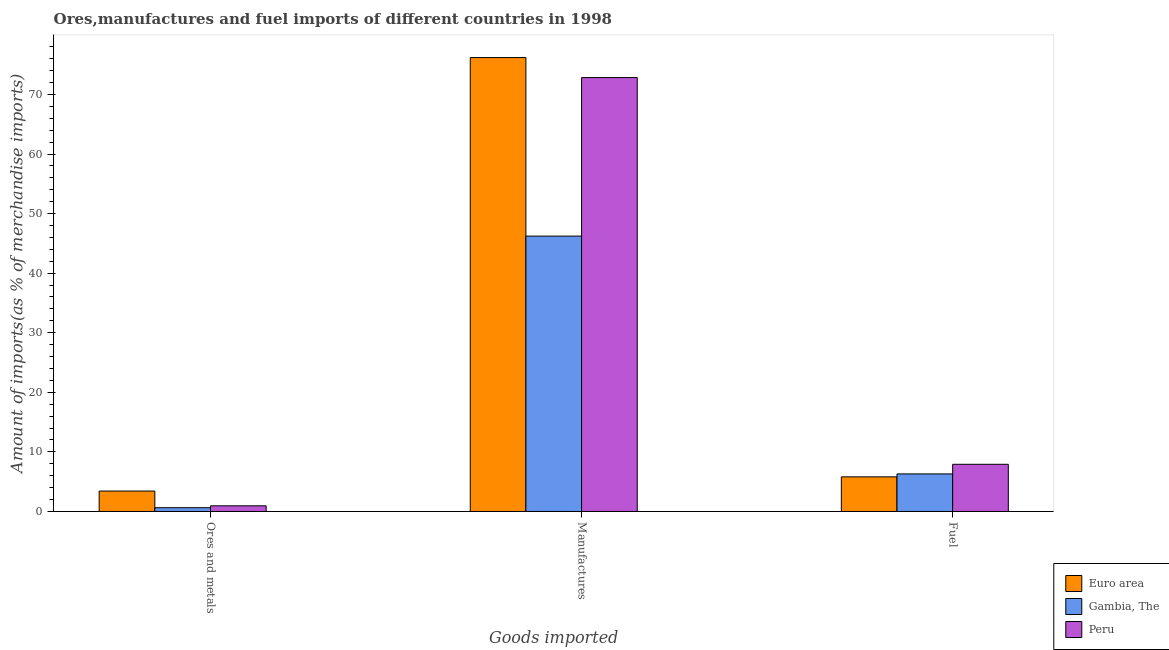How many different coloured bars are there?
Give a very brief answer. 3. Are the number of bars per tick equal to the number of legend labels?
Offer a terse response. Yes. Are the number of bars on each tick of the X-axis equal?
Ensure brevity in your answer.  Yes. How many bars are there on the 3rd tick from the left?
Provide a succinct answer. 3. How many bars are there on the 2nd tick from the right?
Keep it short and to the point. 3. What is the label of the 1st group of bars from the left?
Offer a terse response. Ores and metals. What is the percentage of manufactures imports in Euro area?
Provide a succinct answer. 76.19. Across all countries, what is the maximum percentage of manufactures imports?
Provide a short and direct response. 76.19. Across all countries, what is the minimum percentage of manufactures imports?
Offer a very short reply. 46.22. In which country was the percentage of fuel imports maximum?
Give a very brief answer. Peru. In which country was the percentage of ores and metals imports minimum?
Make the answer very short. Gambia, The. What is the total percentage of ores and metals imports in the graph?
Offer a very short reply. 5.01. What is the difference between the percentage of manufactures imports in Peru and that in Euro area?
Provide a short and direct response. -3.36. What is the difference between the percentage of fuel imports in Gambia, The and the percentage of manufactures imports in Peru?
Your response must be concise. -66.52. What is the average percentage of fuel imports per country?
Provide a succinct answer. 6.68. What is the difference between the percentage of manufactures imports and percentage of fuel imports in Euro area?
Offer a terse response. 70.37. In how many countries, is the percentage of fuel imports greater than 70 %?
Ensure brevity in your answer.  0. What is the ratio of the percentage of manufactures imports in Euro area to that in Gambia, The?
Ensure brevity in your answer.  1.65. Is the difference between the percentage of fuel imports in Peru and Euro area greater than the difference between the percentage of ores and metals imports in Peru and Euro area?
Your answer should be compact. Yes. What is the difference between the highest and the second highest percentage of manufactures imports?
Offer a very short reply. 3.36. What is the difference between the highest and the lowest percentage of fuel imports?
Your response must be concise. 2.11. What does the 3rd bar from the left in Manufactures represents?
Your response must be concise. Peru. What does the 1st bar from the right in Fuel represents?
Make the answer very short. Peru. Is it the case that in every country, the sum of the percentage of ores and metals imports and percentage of manufactures imports is greater than the percentage of fuel imports?
Offer a terse response. Yes. How many bars are there?
Your answer should be compact. 9. How many countries are there in the graph?
Provide a short and direct response. 3. Does the graph contain grids?
Provide a short and direct response. No. Where does the legend appear in the graph?
Keep it short and to the point. Bottom right. How many legend labels are there?
Your response must be concise. 3. How are the legend labels stacked?
Your answer should be compact. Vertical. What is the title of the graph?
Provide a short and direct response. Ores,manufactures and fuel imports of different countries in 1998. What is the label or title of the X-axis?
Give a very brief answer. Goods imported. What is the label or title of the Y-axis?
Keep it short and to the point. Amount of imports(as % of merchandise imports). What is the Amount of imports(as % of merchandise imports) in Euro area in Ores and metals?
Offer a very short reply. 3.43. What is the Amount of imports(as % of merchandise imports) in Gambia, The in Ores and metals?
Provide a short and direct response. 0.63. What is the Amount of imports(as % of merchandise imports) of Peru in Ores and metals?
Provide a short and direct response. 0.95. What is the Amount of imports(as % of merchandise imports) of Euro area in Manufactures?
Offer a terse response. 76.19. What is the Amount of imports(as % of merchandise imports) of Gambia, The in Manufactures?
Offer a terse response. 46.22. What is the Amount of imports(as % of merchandise imports) in Peru in Manufactures?
Provide a short and direct response. 72.83. What is the Amount of imports(as % of merchandise imports) of Euro area in Fuel?
Your answer should be very brief. 5.81. What is the Amount of imports(as % of merchandise imports) of Gambia, The in Fuel?
Give a very brief answer. 6.31. What is the Amount of imports(as % of merchandise imports) in Peru in Fuel?
Keep it short and to the point. 7.92. Across all Goods imported, what is the maximum Amount of imports(as % of merchandise imports) of Euro area?
Your response must be concise. 76.19. Across all Goods imported, what is the maximum Amount of imports(as % of merchandise imports) in Gambia, The?
Keep it short and to the point. 46.22. Across all Goods imported, what is the maximum Amount of imports(as % of merchandise imports) of Peru?
Keep it short and to the point. 72.83. Across all Goods imported, what is the minimum Amount of imports(as % of merchandise imports) in Euro area?
Ensure brevity in your answer.  3.43. Across all Goods imported, what is the minimum Amount of imports(as % of merchandise imports) of Gambia, The?
Your answer should be compact. 0.63. Across all Goods imported, what is the minimum Amount of imports(as % of merchandise imports) in Peru?
Provide a short and direct response. 0.95. What is the total Amount of imports(as % of merchandise imports) of Euro area in the graph?
Make the answer very short. 85.43. What is the total Amount of imports(as % of merchandise imports) of Gambia, The in the graph?
Give a very brief answer. 53.16. What is the total Amount of imports(as % of merchandise imports) in Peru in the graph?
Provide a succinct answer. 81.7. What is the difference between the Amount of imports(as % of merchandise imports) of Euro area in Ores and metals and that in Manufactures?
Offer a terse response. -72.76. What is the difference between the Amount of imports(as % of merchandise imports) in Gambia, The in Ores and metals and that in Manufactures?
Keep it short and to the point. -45.59. What is the difference between the Amount of imports(as % of merchandise imports) in Peru in Ores and metals and that in Manufactures?
Your response must be concise. -71.88. What is the difference between the Amount of imports(as % of merchandise imports) of Euro area in Ores and metals and that in Fuel?
Provide a succinct answer. -2.39. What is the difference between the Amount of imports(as % of merchandise imports) in Gambia, The in Ores and metals and that in Fuel?
Keep it short and to the point. -5.67. What is the difference between the Amount of imports(as % of merchandise imports) in Peru in Ores and metals and that in Fuel?
Offer a terse response. -6.97. What is the difference between the Amount of imports(as % of merchandise imports) in Euro area in Manufactures and that in Fuel?
Offer a terse response. 70.37. What is the difference between the Amount of imports(as % of merchandise imports) of Gambia, The in Manufactures and that in Fuel?
Give a very brief answer. 39.91. What is the difference between the Amount of imports(as % of merchandise imports) in Peru in Manufactures and that in Fuel?
Make the answer very short. 64.91. What is the difference between the Amount of imports(as % of merchandise imports) in Euro area in Ores and metals and the Amount of imports(as % of merchandise imports) in Gambia, The in Manufactures?
Your answer should be compact. -42.79. What is the difference between the Amount of imports(as % of merchandise imports) of Euro area in Ores and metals and the Amount of imports(as % of merchandise imports) of Peru in Manufactures?
Provide a succinct answer. -69.4. What is the difference between the Amount of imports(as % of merchandise imports) in Gambia, The in Ores and metals and the Amount of imports(as % of merchandise imports) in Peru in Manufactures?
Ensure brevity in your answer.  -72.2. What is the difference between the Amount of imports(as % of merchandise imports) of Euro area in Ores and metals and the Amount of imports(as % of merchandise imports) of Gambia, The in Fuel?
Give a very brief answer. -2.88. What is the difference between the Amount of imports(as % of merchandise imports) of Euro area in Ores and metals and the Amount of imports(as % of merchandise imports) of Peru in Fuel?
Your response must be concise. -4.49. What is the difference between the Amount of imports(as % of merchandise imports) in Gambia, The in Ores and metals and the Amount of imports(as % of merchandise imports) in Peru in Fuel?
Ensure brevity in your answer.  -7.29. What is the difference between the Amount of imports(as % of merchandise imports) of Euro area in Manufactures and the Amount of imports(as % of merchandise imports) of Gambia, The in Fuel?
Offer a terse response. 69.88. What is the difference between the Amount of imports(as % of merchandise imports) in Euro area in Manufactures and the Amount of imports(as % of merchandise imports) in Peru in Fuel?
Give a very brief answer. 68.26. What is the difference between the Amount of imports(as % of merchandise imports) in Gambia, The in Manufactures and the Amount of imports(as % of merchandise imports) in Peru in Fuel?
Offer a terse response. 38.3. What is the average Amount of imports(as % of merchandise imports) in Euro area per Goods imported?
Give a very brief answer. 28.48. What is the average Amount of imports(as % of merchandise imports) in Gambia, The per Goods imported?
Provide a short and direct response. 17.72. What is the average Amount of imports(as % of merchandise imports) of Peru per Goods imported?
Ensure brevity in your answer.  27.23. What is the difference between the Amount of imports(as % of merchandise imports) of Euro area and Amount of imports(as % of merchandise imports) of Gambia, The in Ores and metals?
Keep it short and to the point. 2.8. What is the difference between the Amount of imports(as % of merchandise imports) of Euro area and Amount of imports(as % of merchandise imports) of Peru in Ores and metals?
Keep it short and to the point. 2.48. What is the difference between the Amount of imports(as % of merchandise imports) in Gambia, The and Amount of imports(as % of merchandise imports) in Peru in Ores and metals?
Offer a very short reply. -0.32. What is the difference between the Amount of imports(as % of merchandise imports) in Euro area and Amount of imports(as % of merchandise imports) in Gambia, The in Manufactures?
Give a very brief answer. 29.97. What is the difference between the Amount of imports(as % of merchandise imports) of Euro area and Amount of imports(as % of merchandise imports) of Peru in Manufactures?
Your answer should be compact. 3.36. What is the difference between the Amount of imports(as % of merchandise imports) of Gambia, The and Amount of imports(as % of merchandise imports) of Peru in Manufactures?
Offer a terse response. -26.61. What is the difference between the Amount of imports(as % of merchandise imports) of Euro area and Amount of imports(as % of merchandise imports) of Gambia, The in Fuel?
Provide a short and direct response. -0.49. What is the difference between the Amount of imports(as % of merchandise imports) of Euro area and Amount of imports(as % of merchandise imports) of Peru in Fuel?
Keep it short and to the point. -2.11. What is the difference between the Amount of imports(as % of merchandise imports) in Gambia, The and Amount of imports(as % of merchandise imports) in Peru in Fuel?
Keep it short and to the point. -1.61. What is the ratio of the Amount of imports(as % of merchandise imports) of Euro area in Ores and metals to that in Manufactures?
Ensure brevity in your answer.  0.04. What is the ratio of the Amount of imports(as % of merchandise imports) of Gambia, The in Ores and metals to that in Manufactures?
Make the answer very short. 0.01. What is the ratio of the Amount of imports(as % of merchandise imports) in Peru in Ores and metals to that in Manufactures?
Your response must be concise. 0.01. What is the ratio of the Amount of imports(as % of merchandise imports) of Euro area in Ores and metals to that in Fuel?
Provide a succinct answer. 0.59. What is the ratio of the Amount of imports(as % of merchandise imports) in Gambia, The in Ores and metals to that in Fuel?
Offer a terse response. 0.1. What is the ratio of the Amount of imports(as % of merchandise imports) of Peru in Ores and metals to that in Fuel?
Make the answer very short. 0.12. What is the ratio of the Amount of imports(as % of merchandise imports) in Euro area in Manufactures to that in Fuel?
Provide a succinct answer. 13.1. What is the ratio of the Amount of imports(as % of merchandise imports) of Gambia, The in Manufactures to that in Fuel?
Offer a very short reply. 7.33. What is the ratio of the Amount of imports(as % of merchandise imports) of Peru in Manufactures to that in Fuel?
Your response must be concise. 9.2. What is the difference between the highest and the second highest Amount of imports(as % of merchandise imports) in Euro area?
Your answer should be compact. 70.37. What is the difference between the highest and the second highest Amount of imports(as % of merchandise imports) of Gambia, The?
Provide a short and direct response. 39.91. What is the difference between the highest and the second highest Amount of imports(as % of merchandise imports) in Peru?
Keep it short and to the point. 64.91. What is the difference between the highest and the lowest Amount of imports(as % of merchandise imports) in Euro area?
Give a very brief answer. 72.76. What is the difference between the highest and the lowest Amount of imports(as % of merchandise imports) of Gambia, The?
Provide a short and direct response. 45.59. What is the difference between the highest and the lowest Amount of imports(as % of merchandise imports) of Peru?
Your answer should be compact. 71.88. 